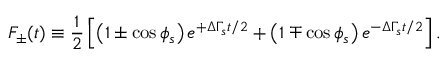<formula> <loc_0><loc_0><loc_500><loc_500>F _ { \pm } ( t ) \equiv \frac { 1 } { 2 } \left [ \left ( 1 \pm \cos \phi _ { s } \right ) e ^ { + \Delta \Gamma _ { s } t / 2 } + \left ( 1 \mp \cos \phi _ { s } \right ) e ^ { - \Delta \Gamma _ { s } t / 2 } \right ] .</formula> 